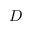Convert formula to latex. <formula><loc_0><loc_0><loc_500><loc_500>D</formula> 